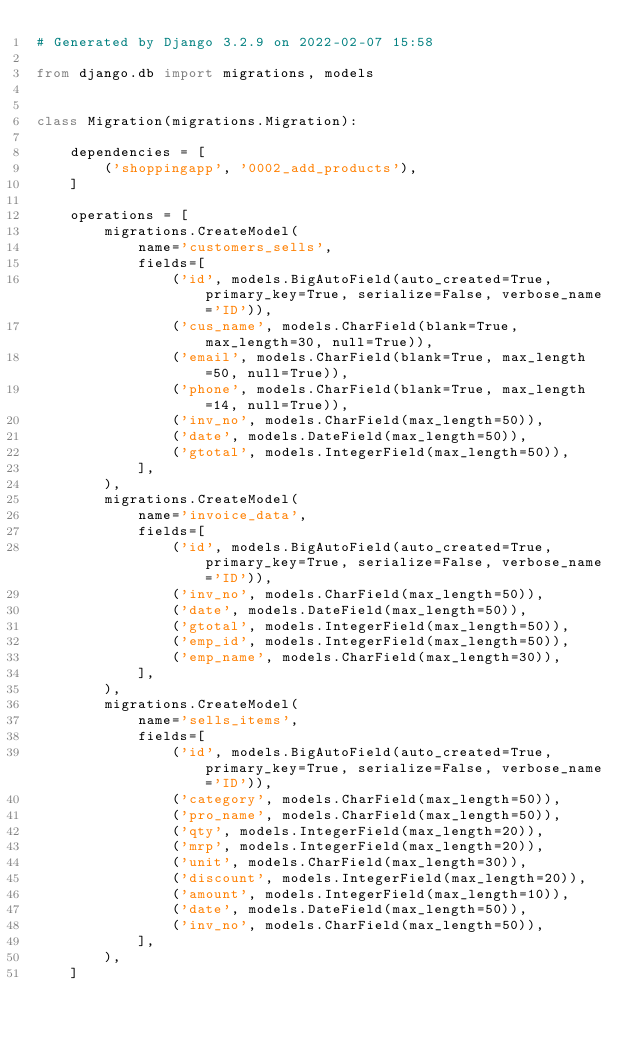Convert code to text. <code><loc_0><loc_0><loc_500><loc_500><_Python_># Generated by Django 3.2.9 on 2022-02-07 15:58

from django.db import migrations, models


class Migration(migrations.Migration):

    dependencies = [
        ('shoppingapp', '0002_add_products'),
    ]

    operations = [
        migrations.CreateModel(
            name='customers_sells',
            fields=[
                ('id', models.BigAutoField(auto_created=True, primary_key=True, serialize=False, verbose_name='ID')),
                ('cus_name', models.CharField(blank=True, max_length=30, null=True)),
                ('email', models.CharField(blank=True, max_length=50, null=True)),
                ('phone', models.CharField(blank=True, max_length=14, null=True)),
                ('inv_no', models.CharField(max_length=50)),
                ('date', models.DateField(max_length=50)),
                ('gtotal', models.IntegerField(max_length=50)),
            ],
        ),
        migrations.CreateModel(
            name='invoice_data',
            fields=[
                ('id', models.BigAutoField(auto_created=True, primary_key=True, serialize=False, verbose_name='ID')),
                ('inv_no', models.CharField(max_length=50)),
                ('date', models.DateField(max_length=50)),
                ('gtotal', models.IntegerField(max_length=50)),
                ('emp_id', models.IntegerField(max_length=50)),
                ('emp_name', models.CharField(max_length=30)),
            ],
        ),
        migrations.CreateModel(
            name='sells_items',
            fields=[
                ('id', models.BigAutoField(auto_created=True, primary_key=True, serialize=False, verbose_name='ID')),
                ('category', models.CharField(max_length=50)),
                ('pro_name', models.CharField(max_length=50)),
                ('qty', models.IntegerField(max_length=20)),
                ('mrp', models.IntegerField(max_length=20)),
                ('unit', models.CharField(max_length=30)),
                ('discount', models.IntegerField(max_length=20)),
                ('amount', models.IntegerField(max_length=10)),
                ('date', models.DateField(max_length=50)),
                ('inv_no', models.CharField(max_length=50)),
            ],
        ),
    ]
</code> 